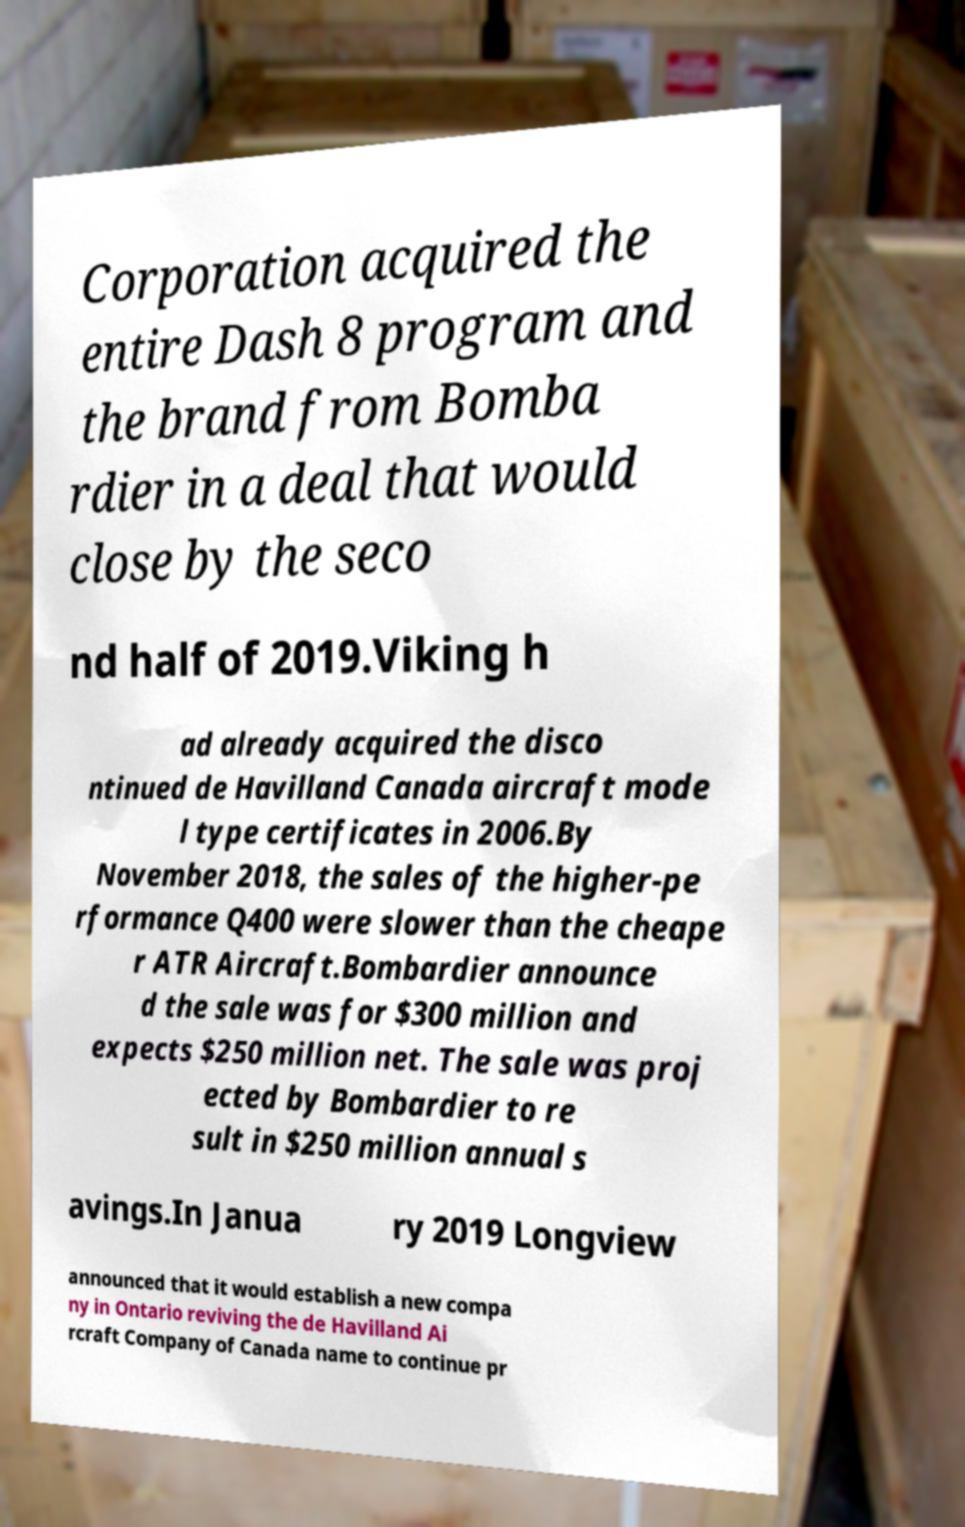Could you extract and type out the text from this image? Corporation acquired the entire Dash 8 program and the brand from Bomba rdier in a deal that would close by the seco nd half of 2019.Viking h ad already acquired the disco ntinued de Havilland Canada aircraft mode l type certificates in 2006.By November 2018, the sales of the higher-pe rformance Q400 were slower than the cheape r ATR Aircraft.Bombardier announce d the sale was for $300 million and expects $250 million net. The sale was proj ected by Bombardier to re sult in $250 million annual s avings.In Janua ry 2019 Longview announced that it would establish a new compa ny in Ontario reviving the de Havilland Ai rcraft Company of Canada name to continue pr 